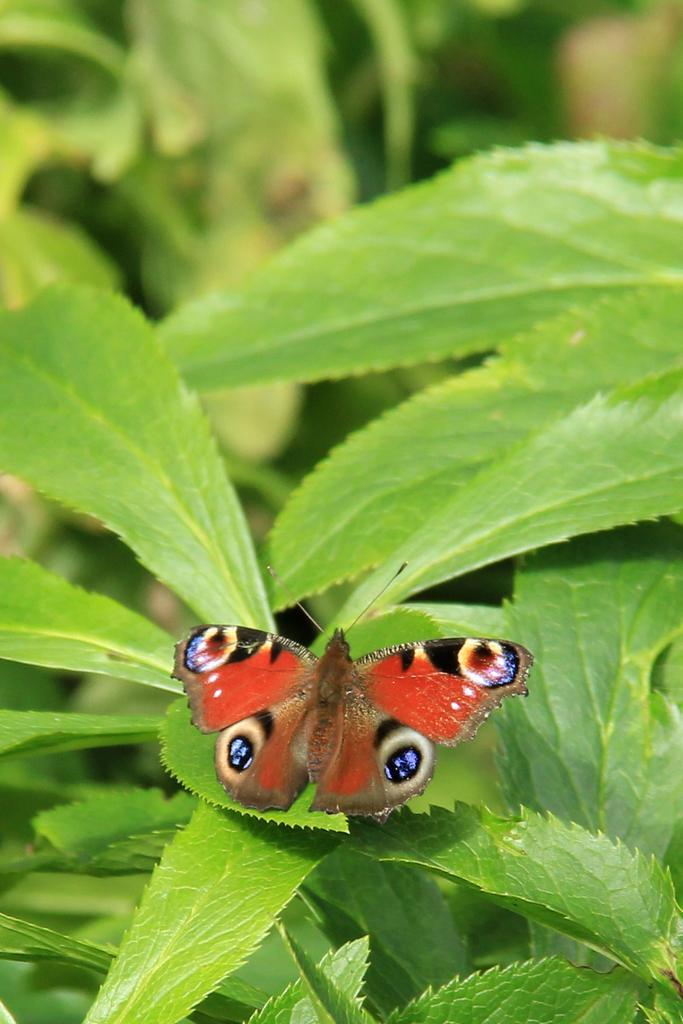How would you summarize this image in a sentence or two? In this image I can see a butterfly with red color and there are some leaves visible. 